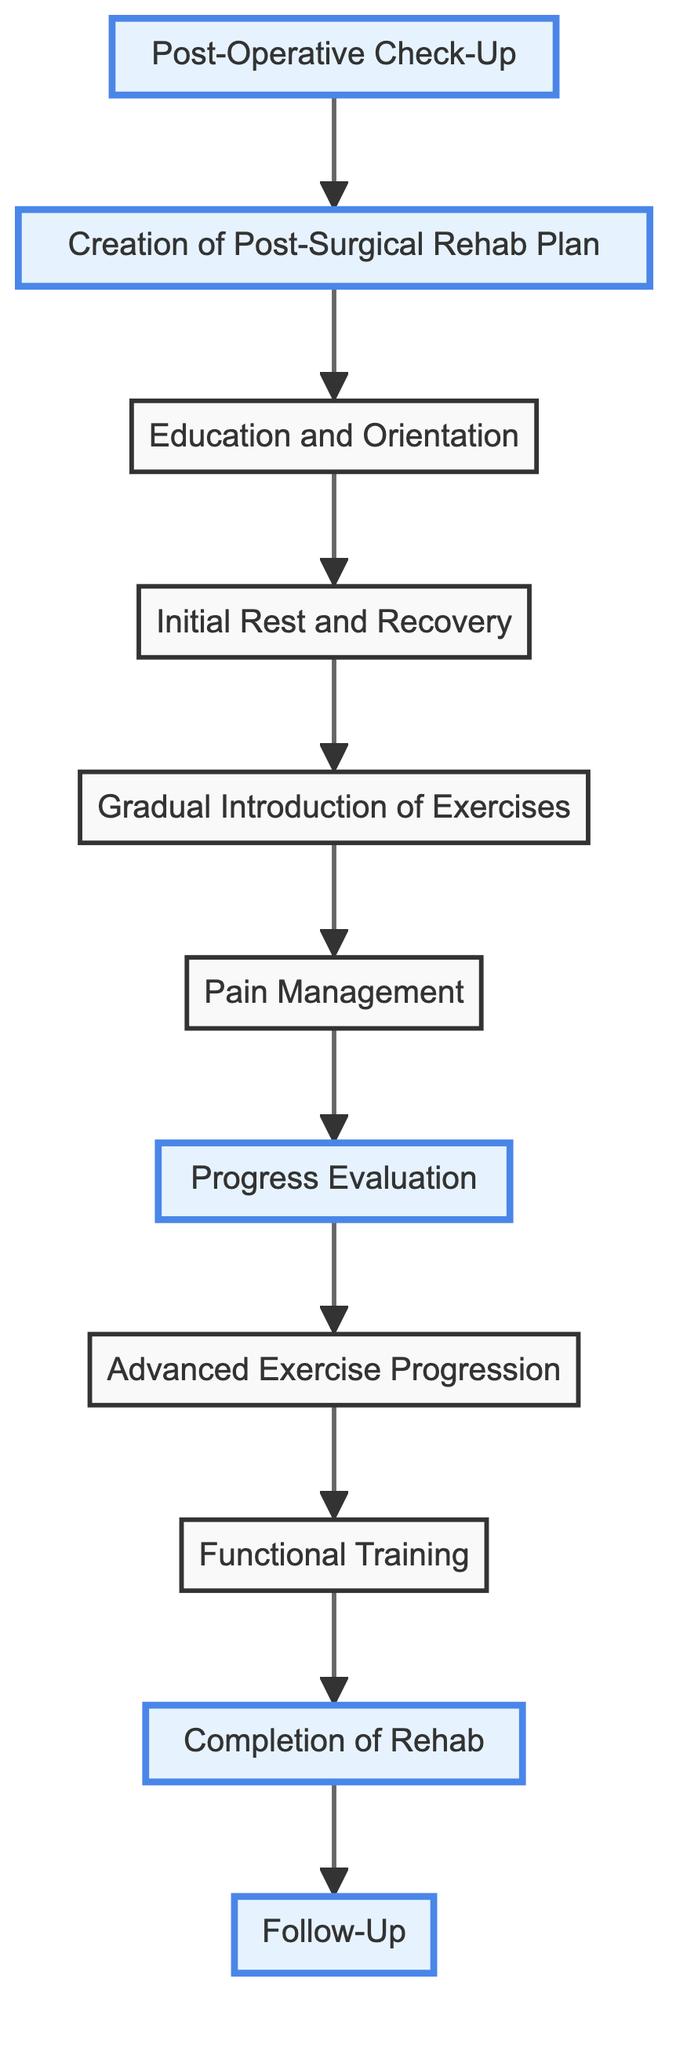What is the first step in the rehabilitation process? The flow chart starts with "Post-Operative Check-Up," which is the initial evaluation performed by the surgeon.
Answer: Post-Operative Check-Up How many main steps are there in the flow chart? Counting all the unique nodes from "Post-Operative Check-Up" to "Follow-Up," we have a total of 11 distinct steps.
Answer: 11 What comes after Education and Orientation? In the flow chart, "Initial Rest and Recovery" follows after "Education and Orientation."
Answer: Initial Rest and Recovery Which step includes pain relief techniques? "Pain Management" is the step that implements techniques for pain relief, which includes medication and ice therapy.
Answer: Pain Management What is the last step in the rehabilitation process? The final step in the flow chart is "Follow-Up," which involves scheduled checks to monitor long-term recovery.
Answer: Follow-Up What is the purpose of "Progress Evaluation"? "Progress Evaluation" is conducted to assess improvements in strength, mobility, and pain levels.
Answer: Assess improvements Which steps are highlighted in the flow chart? The highlighted steps are "Post-Operative Check-Up," "Creation of Post-Surgical Rehab Plan," "Progress Evaluation," "Completion of Rehab," and "Follow-Up."
Answer: 5 steps What follows after the Gradual Introduction of Exercises? "Pain Management" comes immediately after "Gradual Introduction of Exercises" in the process flow.
Answer: Pain Management What type of training occurs before the Completion of Rehab? "Functional Training" occurs before "Completion of Rehab," focusing on exercises that mimic daily activities.
Answer: Functional Training Which two steps focus on assessing competence in recovery? "Progress Evaluation" and "Completion of Rehab" both focus on evaluating the patient's recovery competence.
Answer: Progress Evaluation and Completion of Rehab 